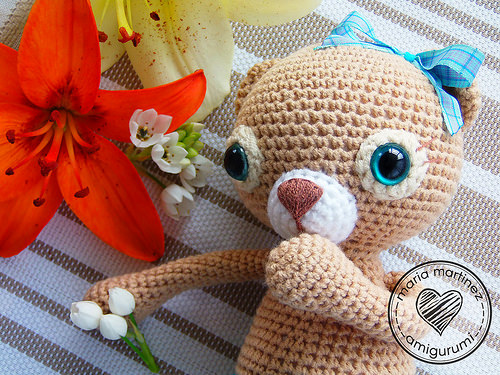<image>
Is there a eyeball above the yarn? No. The eyeball is not positioned above the yarn. The vertical arrangement shows a different relationship. 